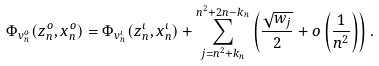<formula> <loc_0><loc_0><loc_500><loc_500>\Phi _ { v ^ { o } _ { n } } ( z ^ { o } _ { n } , x ^ { o } _ { n } ) = \Phi _ { v ^ { \iota } _ { n } } ( z ^ { \iota } _ { n } , x ^ { \iota } _ { n } ) + \sum _ { j = n ^ { 2 } + k _ { n } } ^ { n ^ { 2 } + 2 n - k _ { n } } \left ( \frac { \sqrt { w _ { j } } } { 2 } + o \left ( \frac { 1 } { n ^ { 2 } } \right ) \right ) .</formula> 